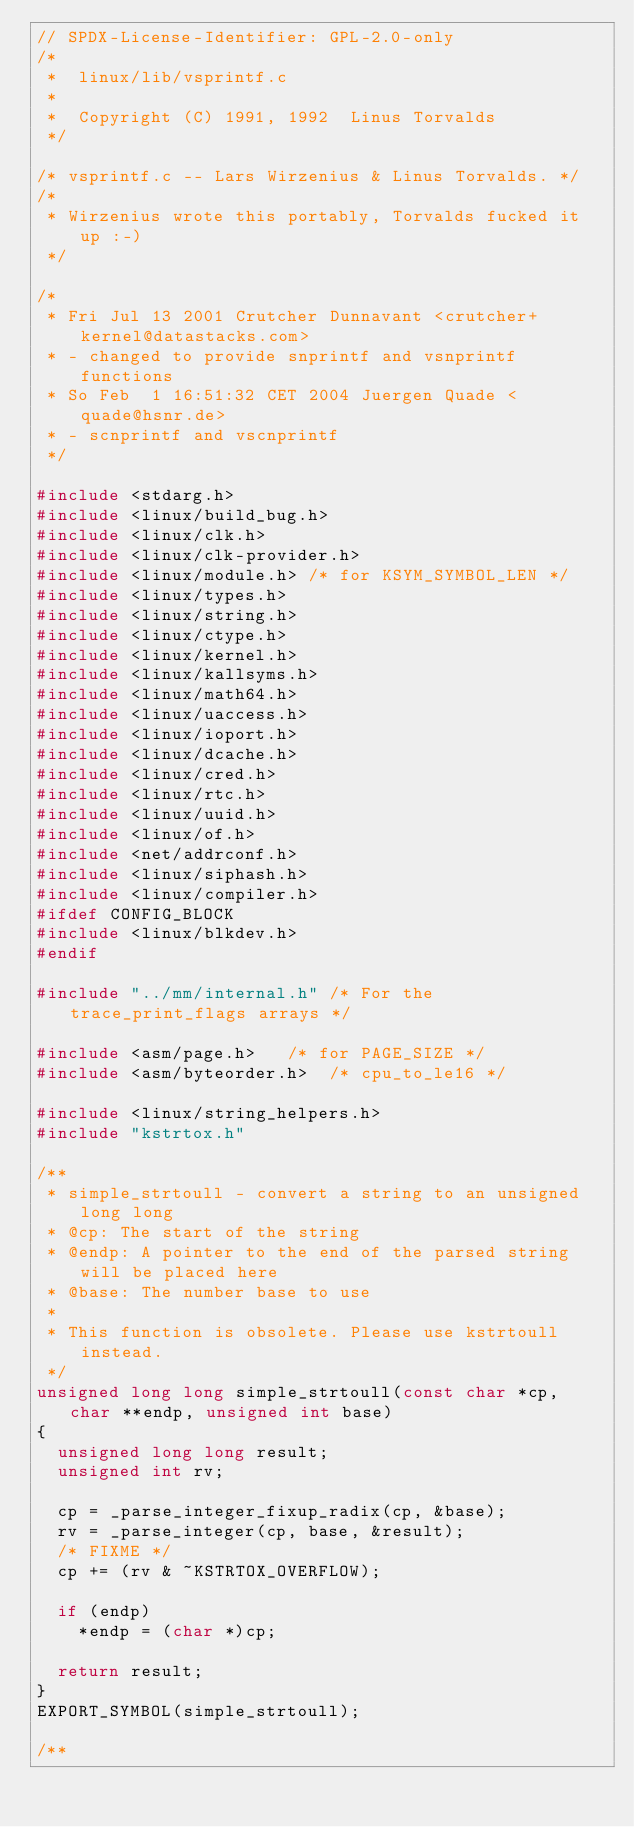Convert code to text. <code><loc_0><loc_0><loc_500><loc_500><_C_>// SPDX-License-Identifier: GPL-2.0-only
/*
 *  linux/lib/vsprintf.c
 *
 *  Copyright (C) 1991, 1992  Linus Torvalds
 */

/* vsprintf.c -- Lars Wirzenius & Linus Torvalds. */
/*
 * Wirzenius wrote this portably, Torvalds fucked it up :-)
 */

/*
 * Fri Jul 13 2001 Crutcher Dunnavant <crutcher+kernel@datastacks.com>
 * - changed to provide snprintf and vsnprintf functions
 * So Feb  1 16:51:32 CET 2004 Juergen Quade <quade@hsnr.de>
 * - scnprintf and vscnprintf
 */

#include <stdarg.h>
#include <linux/build_bug.h>
#include <linux/clk.h>
#include <linux/clk-provider.h>
#include <linux/module.h>	/* for KSYM_SYMBOL_LEN */
#include <linux/types.h>
#include <linux/string.h>
#include <linux/ctype.h>
#include <linux/kernel.h>
#include <linux/kallsyms.h>
#include <linux/math64.h>
#include <linux/uaccess.h>
#include <linux/ioport.h>
#include <linux/dcache.h>
#include <linux/cred.h>
#include <linux/rtc.h>
#include <linux/uuid.h>
#include <linux/of.h>
#include <net/addrconf.h>
#include <linux/siphash.h>
#include <linux/compiler.h>
#ifdef CONFIG_BLOCK
#include <linux/blkdev.h>
#endif

#include "../mm/internal.h"	/* For the trace_print_flags arrays */

#include <asm/page.h>		/* for PAGE_SIZE */
#include <asm/byteorder.h>	/* cpu_to_le16 */

#include <linux/string_helpers.h>
#include "kstrtox.h"

/**
 * simple_strtoull - convert a string to an unsigned long long
 * @cp: The start of the string
 * @endp: A pointer to the end of the parsed string will be placed here
 * @base: The number base to use
 *
 * This function is obsolete. Please use kstrtoull instead.
 */
unsigned long long simple_strtoull(const char *cp, char **endp, unsigned int base)
{
	unsigned long long result;
	unsigned int rv;

	cp = _parse_integer_fixup_radix(cp, &base);
	rv = _parse_integer(cp, base, &result);
	/* FIXME */
	cp += (rv & ~KSTRTOX_OVERFLOW);

	if (endp)
		*endp = (char *)cp;

	return result;
}
EXPORT_SYMBOL(simple_strtoull);

/**</code> 